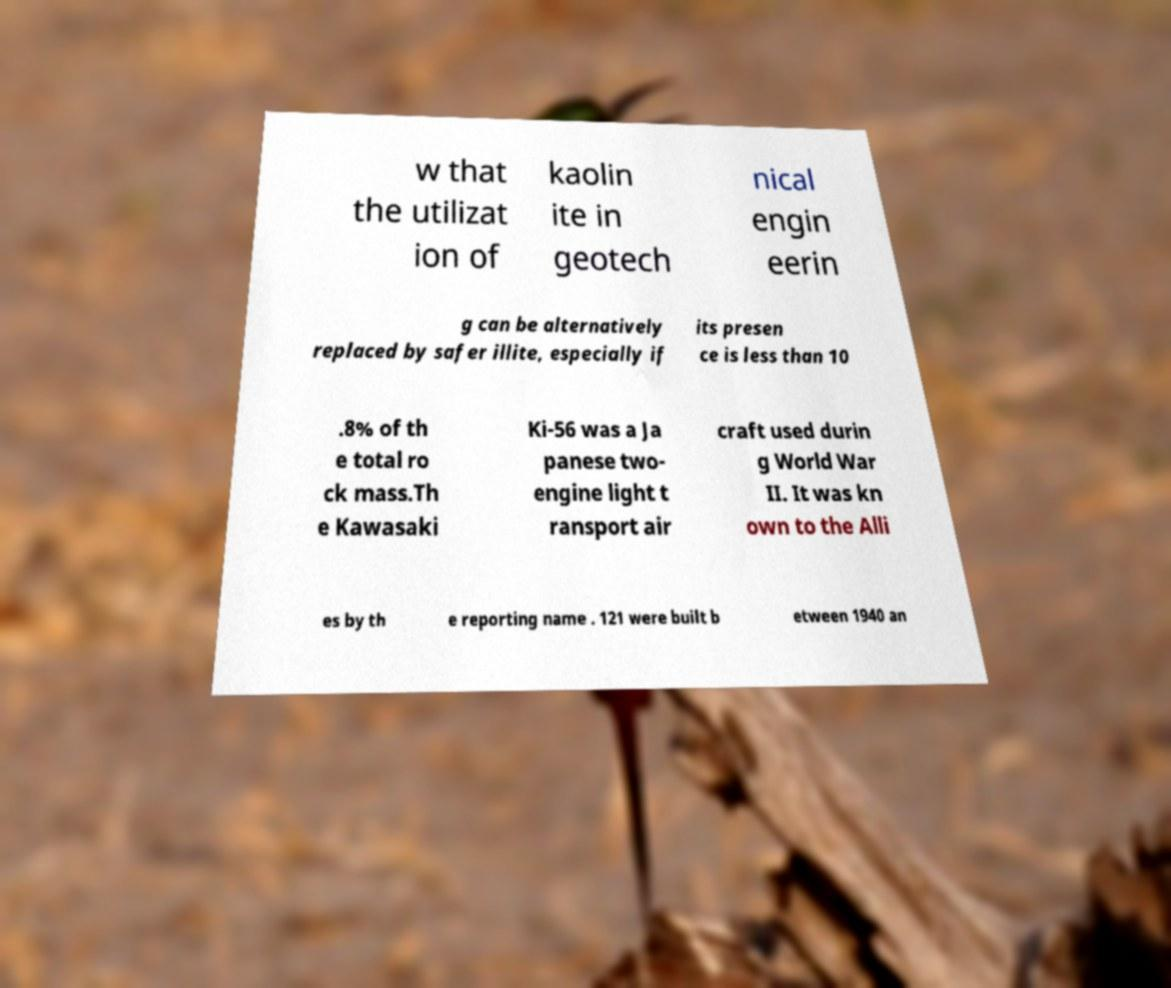What messages or text are displayed in this image? I need them in a readable, typed format. w that the utilizat ion of kaolin ite in geotech nical engin eerin g can be alternatively replaced by safer illite, especially if its presen ce is less than 10 .8% of th e total ro ck mass.Th e Kawasaki Ki-56 was a Ja panese two- engine light t ransport air craft used durin g World War II. It was kn own to the Alli es by th e reporting name . 121 were built b etween 1940 an 